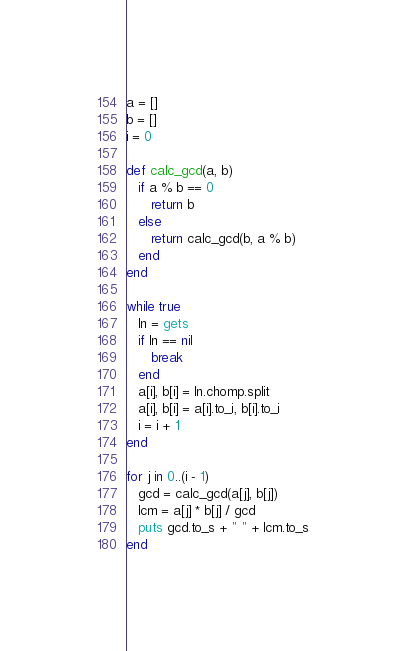Convert code to text. <code><loc_0><loc_0><loc_500><loc_500><_Ruby_>a = []
b = []
i = 0

def calc_gcd(a, b)
   if a % b == 0
      return b
   else
      return calc_gcd(b, a % b)
   end
end

while true
   ln = gets
   if ln == nil
      break
   end
   a[i], b[i] = ln.chomp.split
   a[i], b[i] = a[i].to_i, b[i].to_i
   i = i + 1
end

for j in 0..(i - 1)
   gcd = calc_gcd(a[j], b[j])
   lcm = a[j] * b[j] / gcd
   puts gcd.to_s + " " + lcm.to_s
end
</code> 